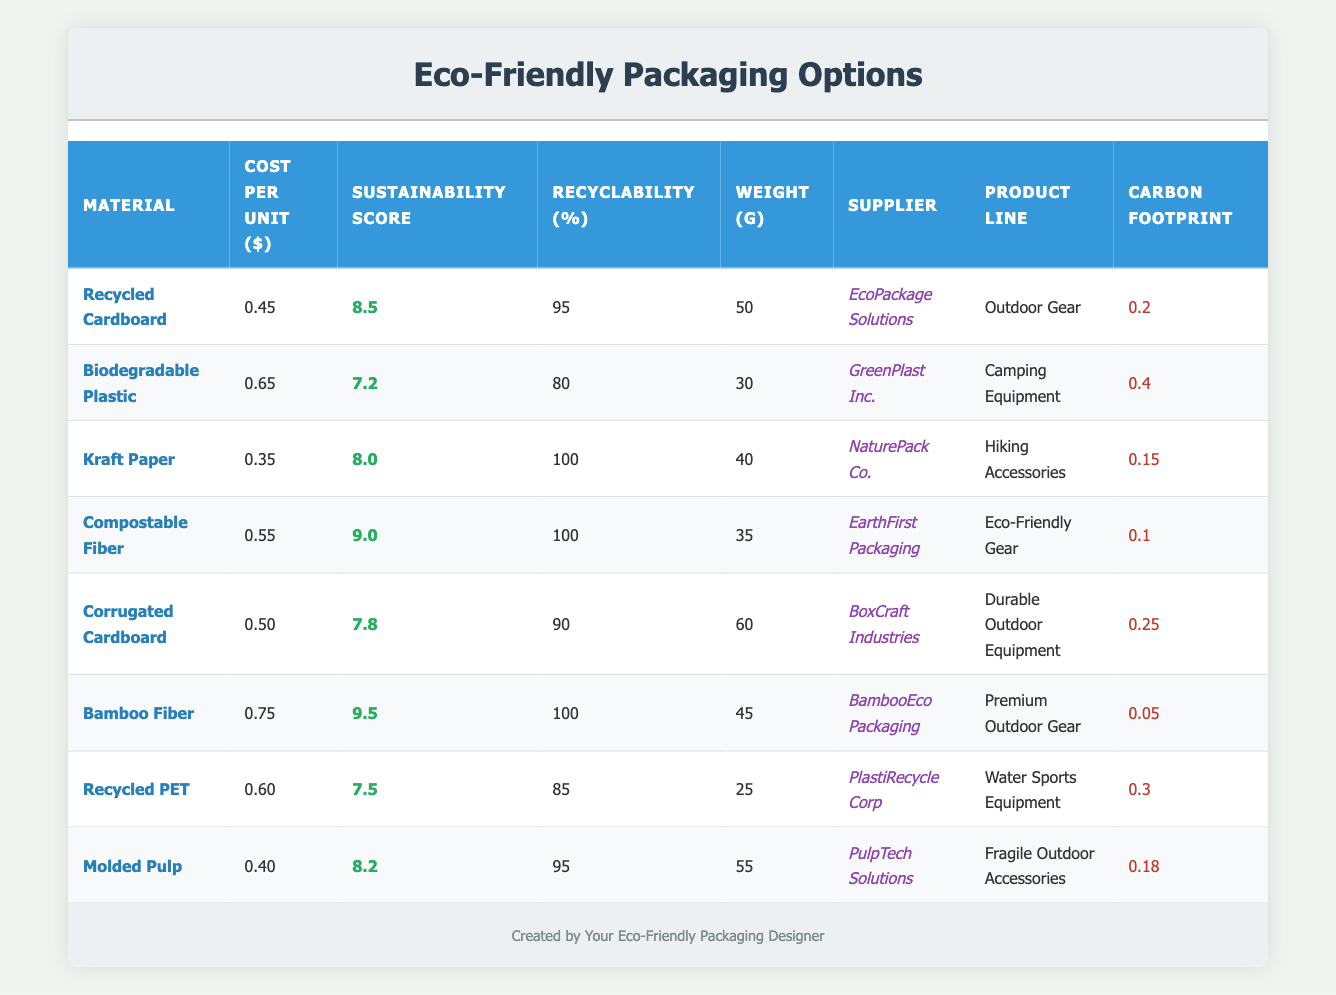What is the cost per unit of Compostable Fiber? The table shows that the cost per unit of Compostable Fiber is listed under the "Cost per Unit ($)" column next to the material's name. The value directly shown is 0.55.
Answer: 0.55 Which material has the highest sustainability score? By looking at the "Sustainability Score" column, we identify the highest value. Bamboo Fiber has a score of 9.5, which is the highest among all materials.
Answer: Bamboo Fiber What is the average recyclability percentage of all packaging materials? To find the average recyclability percentage, sum the recyclability values (95 + 80 + 100 + 100 + 90 + 100 + 85 + 95) = 825. This sum is divided by the number of materials, which is 8. Therefore, the average recyclability is 825/8 = 103.125.
Answer: 103.125 Is the carbon footprint of Biodegradable Plastic lower than that of Recycled PET? We compare the carbon footprint values listed for each material; Biodegradable Plastic has a footprint of 0.4, and Recycled PET has 0.3. Since 0.4 is greater than 0.3, the statement is false.
Answer: No Which supplier provides the lowest cost material? The supplier providing the lowest cost material can be found by checking the "Cost per Unit ($)" column. The lowest cost is 0.35 for Kraft Paper. The corresponding supplier is NaturePack Co.
Answer: NaturePack Co What is the total cost per unit of using Recycled Cardboard, Kraft Paper, and Molded Pulp? First, we find their costs: Recycled Cardboard is 0.45, Kraft Paper is 0.35, and Molded Pulp is 0.40. Summing these values (0.45 + 0.35 + 0.40) results in 1.20.
Answer: 1.20 Does any packaging material have a recyclability percentage of 100? Looking through the "Recyclability (%)" column, we check each value and see that both Kraft Paper and Compostable Fiber have a large recyclability percentage of 100. Thus, the answer to the question is yes.
Answer: Yes Which packaging option has the lowest weight? We compare the weights listed in the "Weight (g)" column. The lowest weight is 25 grams, corresponding to Recycled PET.
Answer: Recycled PET 